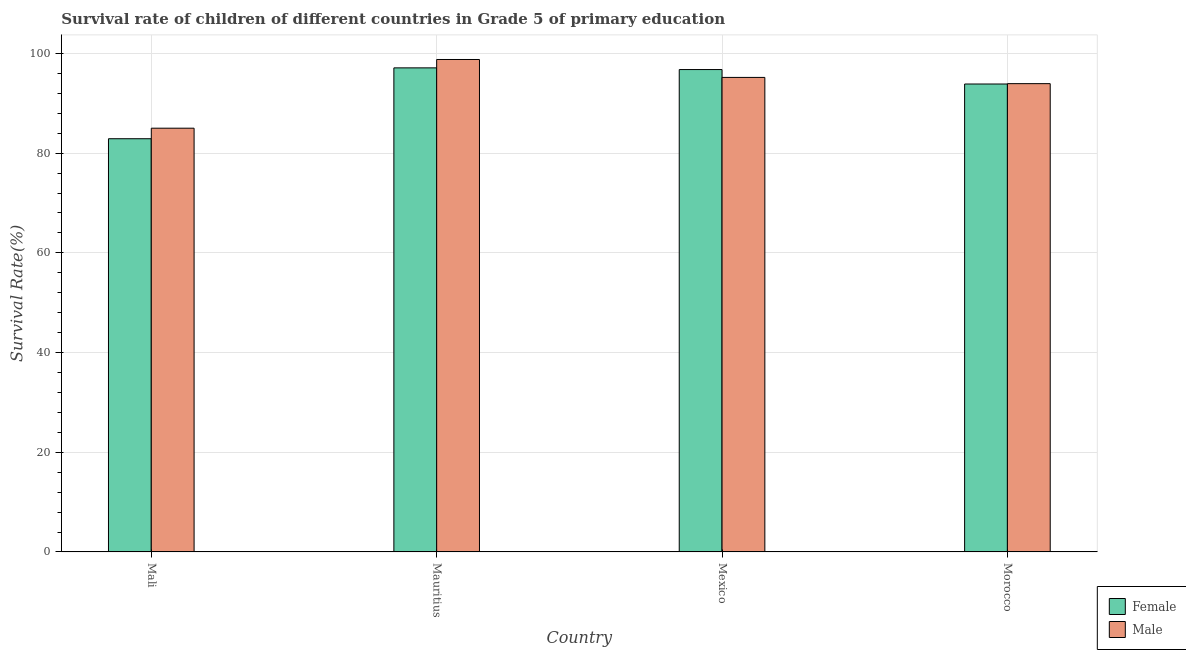How many different coloured bars are there?
Keep it short and to the point. 2. Are the number of bars per tick equal to the number of legend labels?
Your response must be concise. Yes. How many bars are there on the 1st tick from the left?
Provide a succinct answer. 2. What is the label of the 4th group of bars from the left?
Offer a terse response. Morocco. What is the survival rate of female students in primary education in Mauritius?
Offer a terse response. 97.11. Across all countries, what is the maximum survival rate of female students in primary education?
Offer a terse response. 97.11. Across all countries, what is the minimum survival rate of female students in primary education?
Provide a short and direct response. 82.9. In which country was the survival rate of male students in primary education maximum?
Give a very brief answer. Mauritius. In which country was the survival rate of female students in primary education minimum?
Offer a terse response. Mali. What is the total survival rate of female students in primary education in the graph?
Offer a very short reply. 370.65. What is the difference between the survival rate of female students in primary education in Mali and that in Mauritius?
Your answer should be very brief. -14.22. What is the difference between the survival rate of female students in primary education in Mexico and the survival rate of male students in primary education in Mauritius?
Your answer should be compact. -2.02. What is the average survival rate of male students in primary education per country?
Offer a very short reply. 93.24. What is the difference between the survival rate of male students in primary education and survival rate of female students in primary education in Mexico?
Provide a short and direct response. -1.58. What is the ratio of the survival rate of female students in primary education in Mexico to that in Morocco?
Provide a succinct answer. 1.03. Is the survival rate of male students in primary education in Mali less than that in Morocco?
Your answer should be very brief. Yes. What is the difference between the highest and the second highest survival rate of female students in primary education?
Give a very brief answer. 0.34. What is the difference between the highest and the lowest survival rate of male students in primary education?
Your response must be concise. 13.78. In how many countries, is the survival rate of male students in primary education greater than the average survival rate of male students in primary education taken over all countries?
Ensure brevity in your answer.  3. Is the sum of the survival rate of male students in primary education in Mauritius and Mexico greater than the maximum survival rate of female students in primary education across all countries?
Offer a terse response. Yes. What does the 2nd bar from the right in Mali represents?
Keep it short and to the point. Female. How many bars are there?
Offer a very short reply. 8. Are all the bars in the graph horizontal?
Ensure brevity in your answer.  No. Are the values on the major ticks of Y-axis written in scientific E-notation?
Provide a succinct answer. No. Does the graph contain any zero values?
Your answer should be compact. No. What is the title of the graph?
Ensure brevity in your answer.  Survival rate of children of different countries in Grade 5 of primary education. What is the label or title of the X-axis?
Provide a succinct answer. Country. What is the label or title of the Y-axis?
Ensure brevity in your answer.  Survival Rate(%). What is the Survival Rate(%) in Female in Mali?
Your response must be concise. 82.9. What is the Survival Rate(%) of Male in Mali?
Provide a short and direct response. 85.01. What is the Survival Rate(%) of Female in Mauritius?
Give a very brief answer. 97.11. What is the Survival Rate(%) in Male in Mauritius?
Provide a short and direct response. 98.79. What is the Survival Rate(%) in Female in Mexico?
Your answer should be compact. 96.77. What is the Survival Rate(%) in Male in Mexico?
Offer a terse response. 95.2. What is the Survival Rate(%) in Female in Morocco?
Make the answer very short. 93.87. What is the Survival Rate(%) in Male in Morocco?
Your response must be concise. 93.95. Across all countries, what is the maximum Survival Rate(%) in Female?
Provide a succinct answer. 97.11. Across all countries, what is the maximum Survival Rate(%) of Male?
Make the answer very short. 98.79. Across all countries, what is the minimum Survival Rate(%) in Female?
Make the answer very short. 82.9. Across all countries, what is the minimum Survival Rate(%) of Male?
Your response must be concise. 85.01. What is the total Survival Rate(%) of Female in the graph?
Keep it short and to the point. 370.65. What is the total Survival Rate(%) of Male in the graph?
Provide a succinct answer. 372.94. What is the difference between the Survival Rate(%) of Female in Mali and that in Mauritius?
Provide a short and direct response. -14.22. What is the difference between the Survival Rate(%) of Male in Mali and that in Mauritius?
Provide a short and direct response. -13.78. What is the difference between the Survival Rate(%) of Female in Mali and that in Mexico?
Make the answer very short. -13.88. What is the difference between the Survival Rate(%) in Male in Mali and that in Mexico?
Provide a succinct answer. -10.19. What is the difference between the Survival Rate(%) in Female in Mali and that in Morocco?
Your answer should be very brief. -10.98. What is the difference between the Survival Rate(%) in Male in Mali and that in Morocco?
Provide a succinct answer. -8.94. What is the difference between the Survival Rate(%) in Female in Mauritius and that in Mexico?
Make the answer very short. 0.34. What is the difference between the Survival Rate(%) in Male in Mauritius and that in Mexico?
Your answer should be very brief. 3.59. What is the difference between the Survival Rate(%) in Female in Mauritius and that in Morocco?
Give a very brief answer. 3.24. What is the difference between the Survival Rate(%) of Male in Mauritius and that in Morocco?
Provide a short and direct response. 4.84. What is the difference between the Survival Rate(%) in Female in Mexico and that in Morocco?
Provide a short and direct response. 2.9. What is the difference between the Survival Rate(%) in Male in Mexico and that in Morocco?
Offer a very short reply. 1.25. What is the difference between the Survival Rate(%) of Female in Mali and the Survival Rate(%) of Male in Mauritius?
Provide a short and direct response. -15.9. What is the difference between the Survival Rate(%) of Female in Mali and the Survival Rate(%) of Male in Mexico?
Provide a succinct answer. -12.3. What is the difference between the Survival Rate(%) in Female in Mali and the Survival Rate(%) in Male in Morocco?
Your answer should be very brief. -11.05. What is the difference between the Survival Rate(%) in Female in Mauritius and the Survival Rate(%) in Male in Mexico?
Your answer should be compact. 1.92. What is the difference between the Survival Rate(%) in Female in Mauritius and the Survival Rate(%) in Male in Morocco?
Keep it short and to the point. 3.17. What is the difference between the Survival Rate(%) in Female in Mexico and the Survival Rate(%) in Male in Morocco?
Offer a terse response. 2.83. What is the average Survival Rate(%) in Female per country?
Offer a terse response. 92.66. What is the average Survival Rate(%) in Male per country?
Your response must be concise. 93.24. What is the difference between the Survival Rate(%) in Female and Survival Rate(%) in Male in Mali?
Your answer should be compact. -2.11. What is the difference between the Survival Rate(%) in Female and Survival Rate(%) in Male in Mauritius?
Your answer should be compact. -1.68. What is the difference between the Survival Rate(%) in Female and Survival Rate(%) in Male in Mexico?
Make the answer very short. 1.58. What is the difference between the Survival Rate(%) of Female and Survival Rate(%) of Male in Morocco?
Offer a very short reply. -0.07. What is the ratio of the Survival Rate(%) of Female in Mali to that in Mauritius?
Give a very brief answer. 0.85. What is the ratio of the Survival Rate(%) in Male in Mali to that in Mauritius?
Offer a terse response. 0.86. What is the ratio of the Survival Rate(%) in Female in Mali to that in Mexico?
Keep it short and to the point. 0.86. What is the ratio of the Survival Rate(%) of Male in Mali to that in Mexico?
Ensure brevity in your answer.  0.89. What is the ratio of the Survival Rate(%) of Female in Mali to that in Morocco?
Your answer should be compact. 0.88. What is the ratio of the Survival Rate(%) of Male in Mali to that in Morocco?
Your answer should be very brief. 0.9. What is the ratio of the Survival Rate(%) of Female in Mauritius to that in Mexico?
Provide a short and direct response. 1. What is the ratio of the Survival Rate(%) in Male in Mauritius to that in Mexico?
Provide a succinct answer. 1.04. What is the ratio of the Survival Rate(%) of Female in Mauritius to that in Morocco?
Give a very brief answer. 1.03. What is the ratio of the Survival Rate(%) of Male in Mauritius to that in Morocco?
Give a very brief answer. 1.05. What is the ratio of the Survival Rate(%) in Female in Mexico to that in Morocco?
Your answer should be very brief. 1.03. What is the ratio of the Survival Rate(%) in Male in Mexico to that in Morocco?
Provide a succinct answer. 1.01. What is the difference between the highest and the second highest Survival Rate(%) of Female?
Make the answer very short. 0.34. What is the difference between the highest and the second highest Survival Rate(%) of Male?
Ensure brevity in your answer.  3.59. What is the difference between the highest and the lowest Survival Rate(%) of Female?
Offer a terse response. 14.22. What is the difference between the highest and the lowest Survival Rate(%) of Male?
Offer a very short reply. 13.78. 